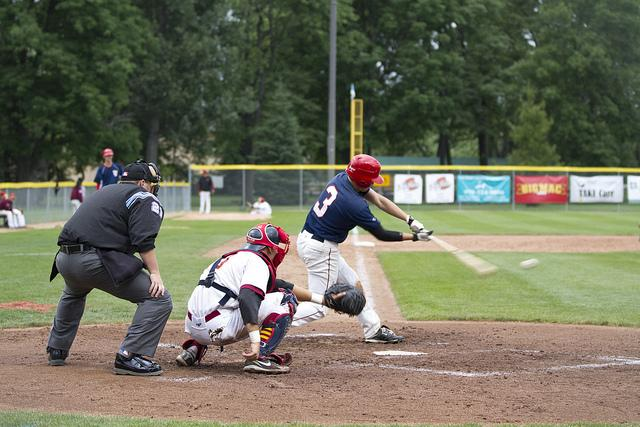What happens in the ball goes over the yellow barrier?

Choices:
A) walk
B) strike
C) home run
D) run home run 